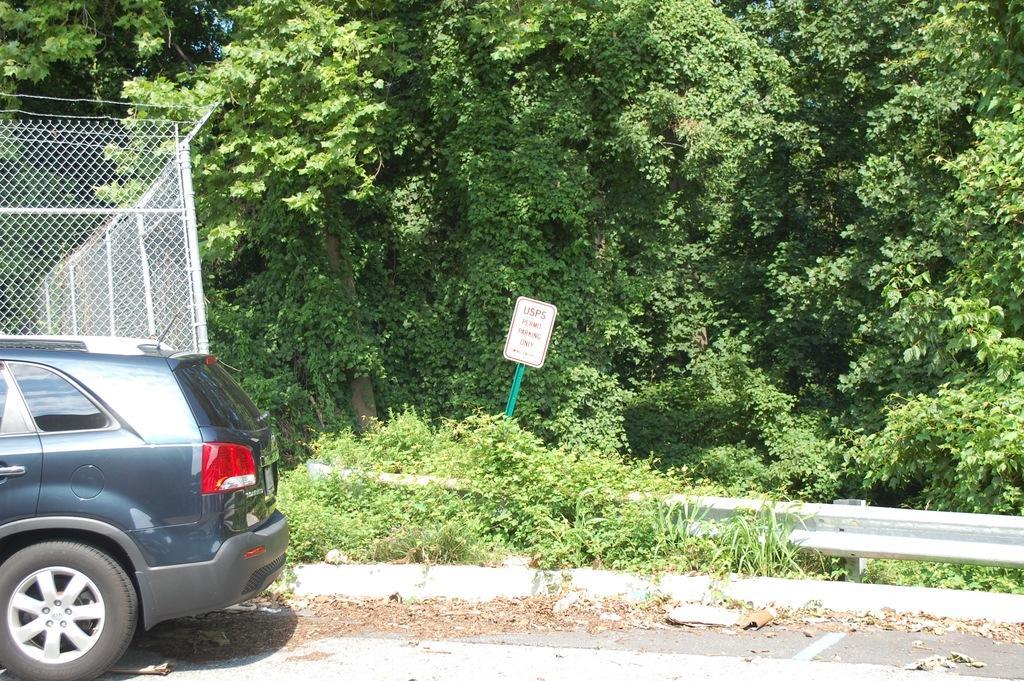Please provide a concise description of this image. In this image we can see there are trees and board. And there is a vehicle on the road, beside the vehicle there is a fence. 